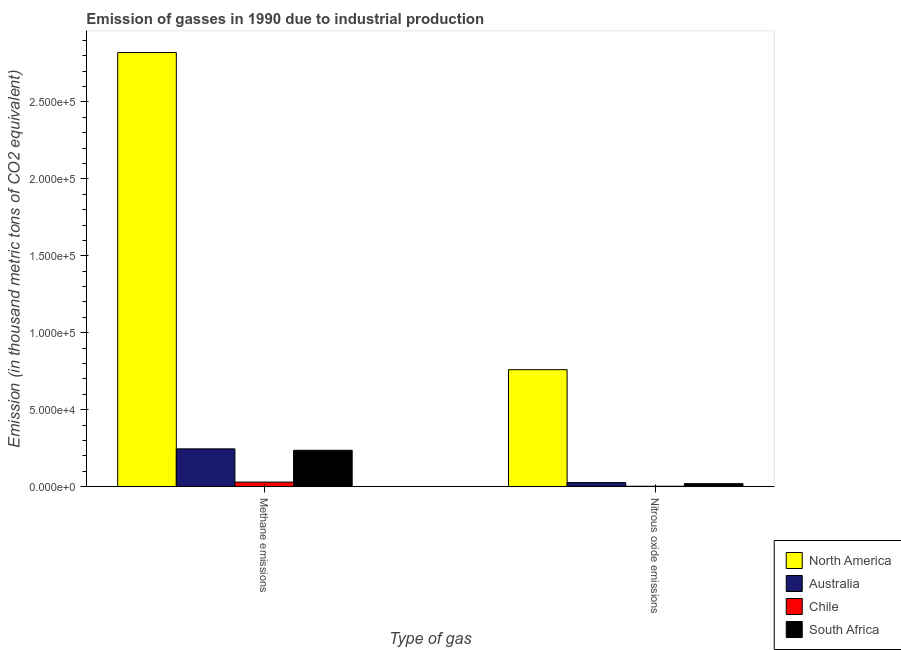How many different coloured bars are there?
Keep it short and to the point. 4. Are the number of bars on each tick of the X-axis equal?
Offer a very short reply. Yes. How many bars are there on the 1st tick from the left?
Your answer should be very brief. 4. What is the label of the 1st group of bars from the left?
Keep it short and to the point. Methane emissions. What is the amount of nitrous oxide emissions in South Africa?
Your answer should be compact. 1978.6. Across all countries, what is the maximum amount of methane emissions?
Your answer should be very brief. 2.82e+05. Across all countries, what is the minimum amount of nitrous oxide emissions?
Your response must be concise. 290.1. In which country was the amount of nitrous oxide emissions maximum?
Your response must be concise. North America. In which country was the amount of nitrous oxide emissions minimum?
Offer a terse response. Chile. What is the total amount of nitrous oxide emissions in the graph?
Provide a succinct answer. 8.10e+04. What is the difference between the amount of methane emissions in South Africa and that in North America?
Offer a terse response. -2.58e+05. What is the difference between the amount of methane emissions in Australia and the amount of nitrous oxide emissions in Chile?
Give a very brief answer. 2.43e+04. What is the average amount of methane emissions per country?
Ensure brevity in your answer.  8.33e+04. What is the difference between the amount of methane emissions and amount of nitrous oxide emissions in Australia?
Provide a succinct answer. 2.19e+04. In how many countries, is the amount of methane emissions greater than 130000 thousand metric tons?
Your answer should be compact. 1. What is the ratio of the amount of methane emissions in South Africa to that in Chile?
Your answer should be compact. 7.88. In how many countries, is the amount of nitrous oxide emissions greater than the average amount of nitrous oxide emissions taken over all countries?
Ensure brevity in your answer.  1. What does the 3rd bar from the left in Nitrous oxide emissions represents?
Your response must be concise. Chile. What does the 4th bar from the right in Methane emissions represents?
Offer a very short reply. North America. How many bars are there?
Provide a succinct answer. 8. Are all the bars in the graph horizontal?
Offer a terse response. No. How many countries are there in the graph?
Your answer should be compact. 4. What is the difference between two consecutive major ticks on the Y-axis?
Ensure brevity in your answer.  5.00e+04. Does the graph contain any zero values?
Your answer should be very brief. No. Does the graph contain grids?
Provide a short and direct response. No. How are the legend labels stacked?
Offer a very short reply. Vertical. What is the title of the graph?
Provide a short and direct response. Emission of gasses in 1990 due to industrial production. What is the label or title of the X-axis?
Your answer should be compact. Type of gas. What is the label or title of the Y-axis?
Offer a terse response. Emission (in thousand metric tons of CO2 equivalent). What is the Emission (in thousand metric tons of CO2 equivalent) in North America in Methane emissions?
Give a very brief answer. 2.82e+05. What is the Emission (in thousand metric tons of CO2 equivalent) in Australia in Methane emissions?
Provide a succinct answer. 2.46e+04. What is the Emission (in thousand metric tons of CO2 equivalent) of Chile in Methane emissions?
Offer a terse response. 3002.7. What is the Emission (in thousand metric tons of CO2 equivalent) of South Africa in Methane emissions?
Provide a short and direct response. 2.36e+04. What is the Emission (in thousand metric tons of CO2 equivalent) in North America in Nitrous oxide emissions?
Make the answer very short. 7.60e+04. What is the Emission (in thousand metric tons of CO2 equivalent) of Australia in Nitrous oxide emissions?
Make the answer very short. 2671. What is the Emission (in thousand metric tons of CO2 equivalent) of Chile in Nitrous oxide emissions?
Your response must be concise. 290.1. What is the Emission (in thousand metric tons of CO2 equivalent) in South Africa in Nitrous oxide emissions?
Ensure brevity in your answer.  1978.6. Across all Type of gas, what is the maximum Emission (in thousand metric tons of CO2 equivalent) of North America?
Your answer should be very brief. 2.82e+05. Across all Type of gas, what is the maximum Emission (in thousand metric tons of CO2 equivalent) in Australia?
Keep it short and to the point. 2.46e+04. Across all Type of gas, what is the maximum Emission (in thousand metric tons of CO2 equivalent) of Chile?
Provide a succinct answer. 3002.7. Across all Type of gas, what is the maximum Emission (in thousand metric tons of CO2 equivalent) in South Africa?
Keep it short and to the point. 2.36e+04. Across all Type of gas, what is the minimum Emission (in thousand metric tons of CO2 equivalent) of North America?
Offer a terse response. 7.60e+04. Across all Type of gas, what is the minimum Emission (in thousand metric tons of CO2 equivalent) in Australia?
Offer a very short reply. 2671. Across all Type of gas, what is the minimum Emission (in thousand metric tons of CO2 equivalent) of Chile?
Provide a succinct answer. 290.1. Across all Type of gas, what is the minimum Emission (in thousand metric tons of CO2 equivalent) of South Africa?
Provide a succinct answer. 1978.6. What is the total Emission (in thousand metric tons of CO2 equivalent) in North America in the graph?
Your response must be concise. 3.58e+05. What is the total Emission (in thousand metric tons of CO2 equivalent) in Australia in the graph?
Provide a succinct answer. 2.72e+04. What is the total Emission (in thousand metric tons of CO2 equivalent) in Chile in the graph?
Keep it short and to the point. 3292.8. What is the total Emission (in thousand metric tons of CO2 equivalent) of South Africa in the graph?
Provide a short and direct response. 2.56e+04. What is the difference between the Emission (in thousand metric tons of CO2 equivalent) of North America in Methane emissions and that in Nitrous oxide emissions?
Your response must be concise. 2.06e+05. What is the difference between the Emission (in thousand metric tons of CO2 equivalent) of Australia in Methane emissions and that in Nitrous oxide emissions?
Offer a very short reply. 2.19e+04. What is the difference between the Emission (in thousand metric tons of CO2 equivalent) of Chile in Methane emissions and that in Nitrous oxide emissions?
Keep it short and to the point. 2712.6. What is the difference between the Emission (in thousand metric tons of CO2 equivalent) in South Africa in Methane emissions and that in Nitrous oxide emissions?
Provide a short and direct response. 2.17e+04. What is the difference between the Emission (in thousand metric tons of CO2 equivalent) of North America in Methane emissions and the Emission (in thousand metric tons of CO2 equivalent) of Australia in Nitrous oxide emissions?
Make the answer very short. 2.79e+05. What is the difference between the Emission (in thousand metric tons of CO2 equivalent) in North America in Methane emissions and the Emission (in thousand metric tons of CO2 equivalent) in Chile in Nitrous oxide emissions?
Make the answer very short. 2.82e+05. What is the difference between the Emission (in thousand metric tons of CO2 equivalent) in North America in Methane emissions and the Emission (in thousand metric tons of CO2 equivalent) in South Africa in Nitrous oxide emissions?
Your response must be concise. 2.80e+05. What is the difference between the Emission (in thousand metric tons of CO2 equivalent) of Australia in Methane emissions and the Emission (in thousand metric tons of CO2 equivalent) of Chile in Nitrous oxide emissions?
Ensure brevity in your answer.  2.43e+04. What is the difference between the Emission (in thousand metric tons of CO2 equivalent) of Australia in Methane emissions and the Emission (in thousand metric tons of CO2 equivalent) of South Africa in Nitrous oxide emissions?
Provide a short and direct response. 2.26e+04. What is the difference between the Emission (in thousand metric tons of CO2 equivalent) in Chile in Methane emissions and the Emission (in thousand metric tons of CO2 equivalent) in South Africa in Nitrous oxide emissions?
Make the answer very short. 1024.1. What is the average Emission (in thousand metric tons of CO2 equivalent) of North America per Type of gas?
Provide a succinct answer. 1.79e+05. What is the average Emission (in thousand metric tons of CO2 equivalent) in Australia per Type of gas?
Provide a succinct answer. 1.36e+04. What is the average Emission (in thousand metric tons of CO2 equivalent) in Chile per Type of gas?
Keep it short and to the point. 1646.4. What is the average Emission (in thousand metric tons of CO2 equivalent) of South Africa per Type of gas?
Offer a very short reply. 1.28e+04. What is the difference between the Emission (in thousand metric tons of CO2 equivalent) in North America and Emission (in thousand metric tons of CO2 equivalent) in Australia in Methane emissions?
Provide a succinct answer. 2.57e+05. What is the difference between the Emission (in thousand metric tons of CO2 equivalent) of North America and Emission (in thousand metric tons of CO2 equivalent) of Chile in Methane emissions?
Provide a succinct answer. 2.79e+05. What is the difference between the Emission (in thousand metric tons of CO2 equivalent) in North America and Emission (in thousand metric tons of CO2 equivalent) in South Africa in Methane emissions?
Give a very brief answer. 2.58e+05. What is the difference between the Emission (in thousand metric tons of CO2 equivalent) of Australia and Emission (in thousand metric tons of CO2 equivalent) of Chile in Methane emissions?
Offer a very short reply. 2.16e+04. What is the difference between the Emission (in thousand metric tons of CO2 equivalent) in Australia and Emission (in thousand metric tons of CO2 equivalent) in South Africa in Methane emissions?
Provide a succinct answer. 920.7. What is the difference between the Emission (in thousand metric tons of CO2 equivalent) of Chile and Emission (in thousand metric tons of CO2 equivalent) of South Africa in Methane emissions?
Keep it short and to the point. -2.06e+04. What is the difference between the Emission (in thousand metric tons of CO2 equivalent) in North America and Emission (in thousand metric tons of CO2 equivalent) in Australia in Nitrous oxide emissions?
Ensure brevity in your answer.  7.34e+04. What is the difference between the Emission (in thousand metric tons of CO2 equivalent) in North America and Emission (in thousand metric tons of CO2 equivalent) in Chile in Nitrous oxide emissions?
Keep it short and to the point. 7.57e+04. What is the difference between the Emission (in thousand metric tons of CO2 equivalent) in North America and Emission (in thousand metric tons of CO2 equivalent) in South Africa in Nitrous oxide emissions?
Provide a succinct answer. 7.40e+04. What is the difference between the Emission (in thousand metric tons of CO2 equivalent) in Australia and Emission (in thousand metric tons of CO2 equivalent) in Chile in Nitrous oxide emissions?
Offer a terse response. 2380.9. What is the difference between the Emission (in thousand metric tons of CO2 equivalent) of Australia and Emission (in thousand metric tons of CO2 equivalent) of South Africa in Nitrous oxide emissions?
Provide a short and direct response. 692.4. What is the difference between the Emission (in thousand metric tons of CO2 equivalent) of Chile and Emission (in thousand metric tons of CO2 equivalent) of South Africa in Nitrous oxide emissions?
Your answer should be compact. -1688.5. What is the ratio of the Emission (in thousand metric tons of CO2 equivalent) of North America in Methane emissions to that in Nitrous oxide emissions?
Your answer should be very brief. 3.71. What is the ratio of the Emission (in thousand metric tons of CO2 equivalent) in Australia in Methane emissions to that in Nitrous oxide emissions?
Provide a short and direct response. 9.2. What is the ratio of the Emission (in thousand metric tons of CO2 equivalent) of Chile in Methane emissions to that in Nitrous oxide emissions?
Your response must be concise. 10.35. What is the ratio of the Emission (in thousand metric tons of CO2 equivalent) of South Africa in Methane emissions to that in Nitrous oxide emissions?
Keep it short and to the point. 11.95. What is the difference between the highest and the second highest Emission (in thousand metric tons of CO2 equivalent) in North America?
Keep it short and to the point. 2.06e+05. What is the difference between the highest and the second highest Emission (in thousand metric tons of CO2 equivalent) in Australia?
Your answer should be compact. 2.19e+04. What is the difference between the highest and the second highest Emission (in thousand metric tons of CO2 equivalent) of Chile?
Provide a succinct answer. 2712.6. What is the difference between the highest and the second highest Emission (in thousand metric tons of CO2 equivalent) in South Africa?
Offer a very short reply. 2.17e+04. What is the difference between the highest and the lowest Emission (in thousand metric tons of CO2 equivalent) of North America?
Your response must be concise. 2.06e+05. What is the difference between the highest and the lowest Emission (in thousand metric tons of CO2 equivalent) of Australia?
Your response must be concise. 2.19e+04. What is the difference between the highest and the lowest Emission (in thousand metric tons of CO2 equivalent) in Chile?
Keep it short and to the point. 2712.6. What is the difference between the highest and the lowest Emission (in thousand metric tons of CO2 equivalent) of South Africa?
Offer a terse response. 2.17e+04. 